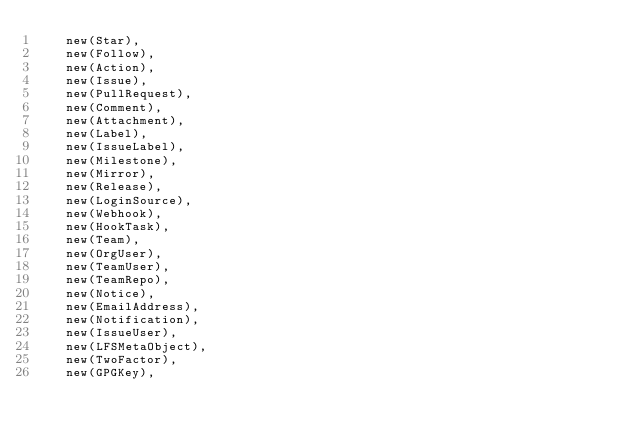Convert code to text. <code><loc_0><loc_0><loc_500><loc_500><_Go_>		new(Star),
		new(Follow),
		new(Action),
		new(Issue),
		new(PullRequest),
		new(Comment),
		new(Attachment),
		new(Label),
		new(IssueLabel),
		new(Milestone),
		new(Mirror),
		new(Release),
		new(LoginSource),
		new(Webhook),
		new(HookTask),
		new(Team),
		new(OrgUser),
		new(TeamUser),
		new(TeamRepo),
		new(Notice),
		new(EmailAddress),
		new(Notification),
		new(IssueUser),
		new(LFSMetaObject),
		new(TwoFactor),
		new(GPGKey),</code> 